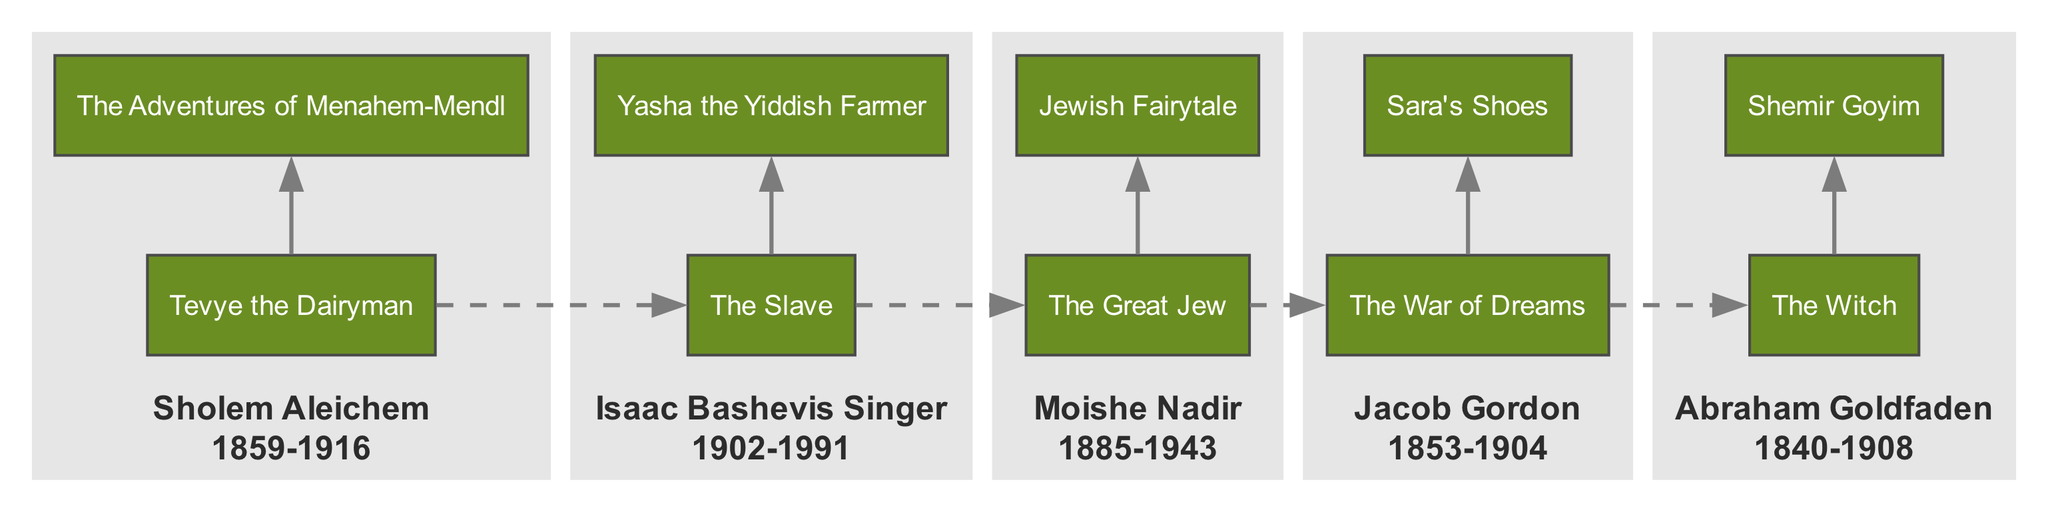What are the major works of Sholem Aleichem? The diagram shows "Tevye the Dairyman" and "The Adventures of Menahem-Mendl" listed under Sholem Aleichem, confirming these as his major works.
Answer: Tevye the Dairyman, The Adventures of Menahem-Mendl Which playwright had a major work titled "The Slave"? In the diagram, Isaac Bashevis Singer is associated with the major work "The Slave," indicating he is the playwright responsible for it.
Answer: Isaac Bashevis Singer How many major works are attributed to Moishe Nadir? The diagram lists two major works under Moishe Nadir: "The Great Jew" and "Jewish Fairytale," indicating he has two major works.
Answer: 2 Which playwright's time period spans from 1840 to 1908? The diagram shows Abraham Goldfaden's name accompanied by the time period "1840-1908," confirming he is the playwright from this time frame.
Answer: Abraham Goldfaden What is the relationship between Jacob Gordon's works and Sholem Aleichem's works? In the diagram, there is a dashed edge connecting the first major work of Jacob Gordon to the first major work of Sholem Aleichem, suggesting a chronological relationship between their works.
Answer: Chronological relationship Which playwright's major works are visually connected, and how? The diagram visually connects the major works of each playwright within their subgraphs. For instance, Sholem Aleichem's works are connected to each other, indicating a relationship among his works.
Answer: Visually connected within subgraphs How many total playwrights are represented in the diagram? The diagram contains five playwrights listed, which can be counted within the relevant sections of the diagram.
Answer: 5 Which playwright is associated with the works "The War of Dreams" and "Sara's Shoes"? The diagram shows that both "The War of Dreams" and "Sara's Shoes" are listed under Jacob Gordon, establishing him as the associated playwright.
Answer: Jacob Gordon Which major work corresponds to the playwright with a time period from 1902 to 1991? According to the diagram, the playwright Isaac Bashevis Singer corresponds to the time period "1902-1991" and is associated with works such as "The Slave."
Answer: The Slave 